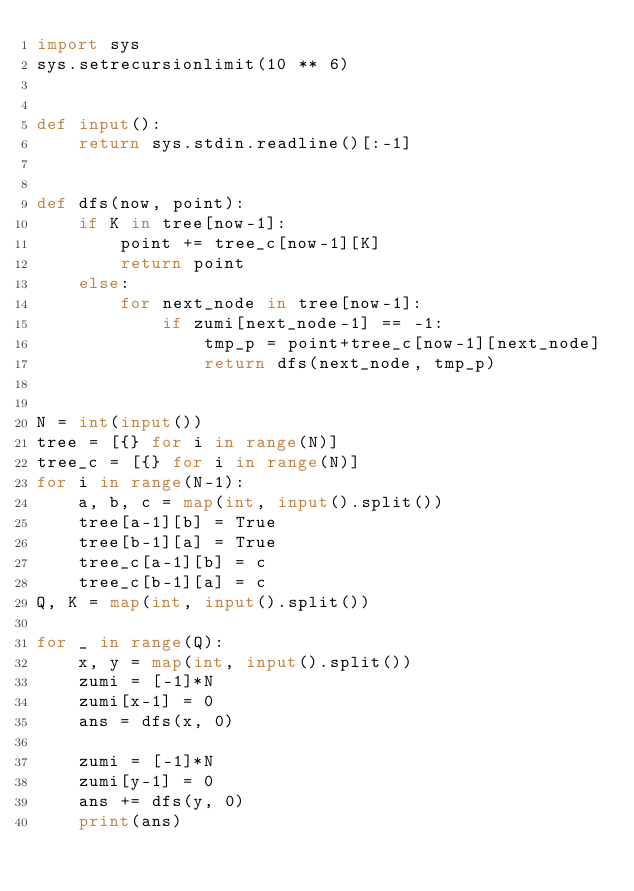Convert code to text. <code><loc_0><loc_0><loc_500><loc_500><_Python_>import sys
sys.setrecursionlimit(10 ** 6)


def input():
    return sys.stdin.readline()[:-1]


def dfs(now, point):
    if K in tree[now-1]:
        point += tree_c[now-1][K]
        return point
    else:
        for next_node in tree[now-1]:
            if zumi[next_node-1] == -1:
                tmp_p = point+tree_c[now-1][next_node]
                return dfs(next_node, tmp_p)


N = int(input())
tree = [{} for i in range(N)]
tree_c = [{} for i in range(N)]
for i in range(N-1):
    a, b, c = map(int, input().split())
    tree[a-1][b] = True
    tree[b-1][a] = True
    tree_c[a-1][b] = c
    tree_c[b-1][a] = c
Q, K = map(int, input().split())

for _ in range(Q):
    x, y = map(int, input().split())
    zumi = [-1]*N
    zumi[x-1] = 0
    ans = dfs(x, 0)

    zumi = [-1]*N
    zumi[y-1] = 0
    ans += dfs(y, 0)
    print(ans)
</code> 